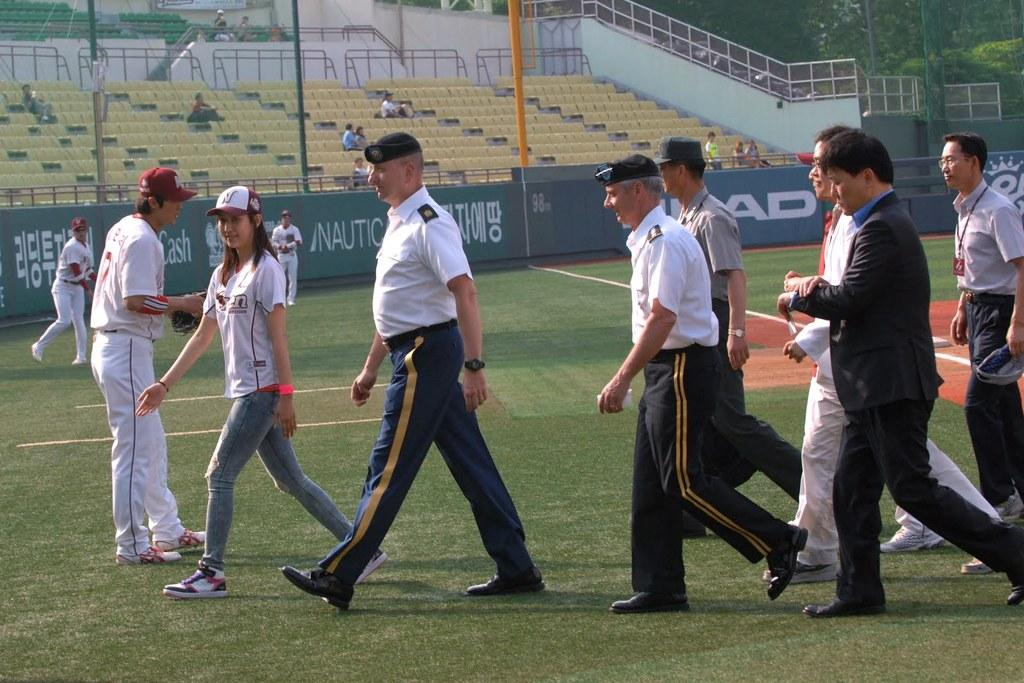How many people are in the image? There is a group of people in the image, but the exact number is not specified. What are some of the people in the image doing? Some people are sitting on chairs, while others are walking on the ground. What can be seen in the background of the image? There are trees in the background of the image. What structures are present in the image? There is a wall and fences in the image. What type of soda is being served at the playground in the image? There is no playground or soda present in the image. How many answers can be found in the image? The image does not contain any questions or answers; it is a scene with people, chairs, walls, fences, and trees. 